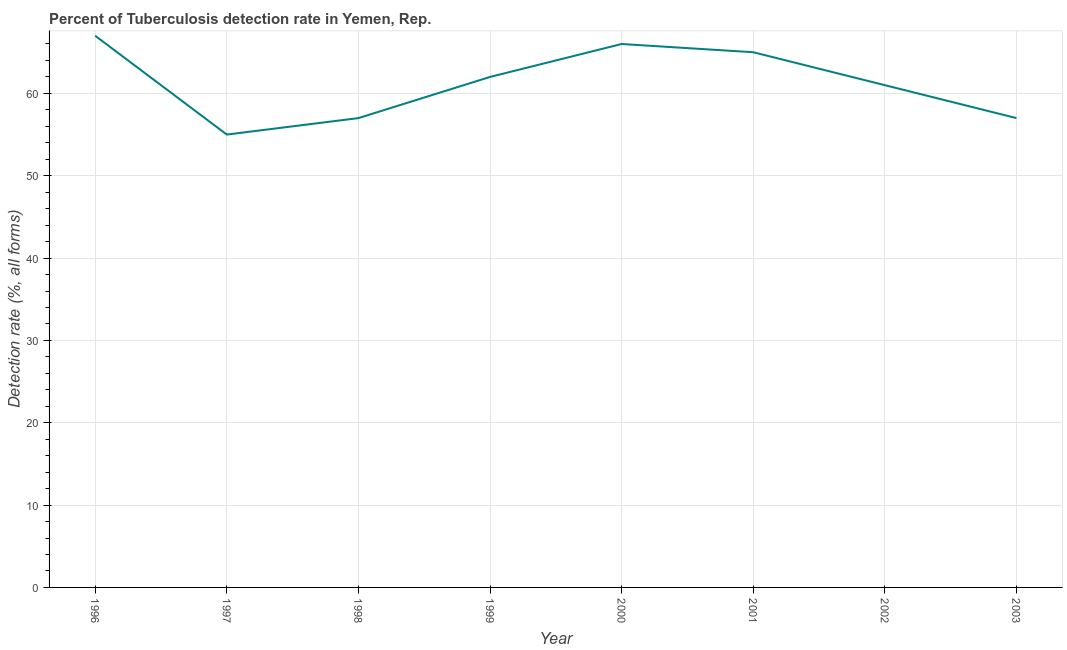What is the detection rate of tuberculosis in 1998?
Ensure brevity in your answer.  57. Across all years, what is the maximum detection rate of tuberculosis?
Your answer should be compact. 67. Across all years, what is the minimum detection rate of tuberculosis?
Make the answer very short. 55. What is the sum of the detection rate of tuberculosis?
Your response must be concise. 490. What is the difference between the detection rate of tuberculosis in 1998 and 2000?
Keep it short and to the point. -9. What is the average detection rate of tuberculosis per year?
Ensure brevity in your answer.  61.25. What is the median detection rate of tuberculosis?
Your answer should be compact. 61.5. In how many years, is the detection rate of tuberculosis greater than 40 %?
Provide a succinct answer. 8. Do a majority of the years between 1999 and 1996 (inclusive) have detection rate of tuberculosis greater than 28 %?
Your answer should be compact. Yes. What is the ratio of the detection rate of tuberculosis in 1996 to that in 1998?
Your answer should be very brief. 1.18. Is the difference between the detection rate of tuberculosis in 1997 and 2002 greater than the difference between any two years?
Offer a terse response. No. What is the difference between the highest and the second highest detection rate of tuberculosis?
Keep it short and to the point. 1. What is the difference between the highest and the lowest detection rate of tuberculosis?
Your answer should be very brief. 12. In how many years, is the detection rate of tuberculosis greater than the average detection rate of tuberculosis taken over all years?
Your answer should be very brief. 4. Does the detection rate of tuberculosis monotonically increase over the years?
Your answer should be very brief. No. How many lines are there?
Ensure brevity in your answer.  1. Are the values on the major ticks of Y-axis written in scientific E-notation?
Give a very brief answer. No. Does the graph contain any zero values?
Offer a very short reply. No. What is the title of the graph?
Provide a succinct answer. Percent of Tuberculosis detection rate in Yemen, Rep. What is the label or title of the Y-axis?
Your answer should be very brief. Detection rate (%, all forms). What is the Detection rate (%, all forms) of 1997?
Keep it short and to the point. 55. What is the Detection rate (%, all forms) of 1999?
Provide a short and direct response. 62. What is the Detection rate (%, all forms) in 2003?
Offer a very short reply. 57. What is the difference between the Detection rate (%, all forms) in 1996 and 1999?
Your answer should be very brief. 5. What is the difference between the Detection rate (%, all forms) in 1996 and 2001?
Offer a terse response. 2. What is the difference between the Detection rate (%, all forms) in 1997 and 1999?
Offer a very short reply. -7. What is the difference between the Detection rate (%, all forms) in 1997 and 2001?
Ensure brevity in your answer.  -10. What is the difference between the Detection rate (%, all forms) in 1997 and 2002?
Offer a very short reply. -6. What is the difference between the Detection rate (%, all forms) in 1997 and 2003?
Make the answer very short. -2. What is the difference between the Detection rate (%, all forms) in 1998 and 2001?
Your answer should be very brief. -8. What is the difference between the Detection rate (%, all forms) in 1998 and 2002?
Ensure brevity in your answer.  -4. What is the difference between the Detection rate (%, all forms) in 1999 and 2001?
Ensure brevity in your answer.  -3. What is the difference between the Detection rate (%, all forms) in 1999 and 2002?
Offer a very short reply. 1. What is the difference between the Detection rate (%, all forms) in 1999 and 2003?
Make the answer very short. 5. What is the difference between the Detection rate (%, all forms) in 2000 and 2003?
Your answer should be compact. 9. What is the difference between the Detection rate (%, all forms) in 2001 and 2003?
Provide a short and direct response. 8. What is the difference between the Detection rate (%, all forms) in 2002 and 2003?
Ensure brevity in your answer.  4. What is the ratio of the Detection rate (%, all forms) in 1996 to that in 1997?
Ensure brevity in your answer.  1.22. What is the ratio of the Detection rate (%, all forms) in 1996 to that in 1998?
Offer a terse response. 1.18. What is the ratio of the Detection rate (%, all forms) in 1996 to that in 1999?
Provide a succinct answer. 1.08. What is the ratio of the Detection rate (%, all forms) in 1996 to that in 2000?
Your response must be concise. 1.01. What is the ratio of the Detection rate (%, all forms) in 1996 to that in 2001?
Ensure brevity in your answer.  1.03. What is the ratio of the Detection rate (%, all forms) in 1996 to that in 2002?
Ensure brevity in your answer.  1.1. What is the ratio of the Detection rate (%, all forms) in 1996 to that in 2003?
Offer a terse response. 1.18. What is the ratio of the Detection rate (%, all forms) in 1997 to that in 1999?
Provide a short and direct response. 0.89. What is the ratio of the Detection rate (%, all forms) in 1997 to that in 2000?
Your answer should be compact. 0.83. What is the ratio of the Detection rate (%, all forms) in 1997 to that in 2001?
Offer a very short reply. 0.85. What is the ratio of the Detection rate (%, all forms) in 1997 to that in 2002?
Your response must be concise. 0.9. What is the ratio of the Detection rate (%, all forms) in 1997 to that in 2003?
Offer a very short reply. 0.96. What is the ratio of the Detection rate (%, all forms) in 1998 to that in 1999?
Your answer should be compact. 0.92. What is the ratio of the Detection rate (%, all forms) in 1998 to that in 2000?
Ensure brevity in your answer.  0.86. What is the ratio of the Detection rate (%, all forms) in 1998 to that in 2001?
Make the answer very short. 0.88. What is the ratio of the Detection rate (%, all forms) in 1998 to that in 2002?
Make the answer very short. 0.93. What is the ratio of the Detection rate (%, all forms) in 1998 to that in 2003?
Offer a very short reply. 1. What is the ratio of the Detection rate (%, all forms) in 1999 to that in 2000?
Your answer should be compact. 0.94. What is the ratio of the Detection rate (%, all forms) in 1999 to that in 2001?
Your answer should be compact. 0.95. What is the ratio of the Detection rate (%, all forms) in 1999 to that in 2002?
Provide a short and direct response. 1.02. What is the ratio of the Detection rate (%, all forms) in 1999 to that in 2003?
Keep it short and to the point. 1.09. What is the ratio of the Detection rate (%, all forms) in 2000 to that in 2002?
Your answer should be compact. 1.08. What is the ratio of the Detection rate (%, all forms) in 2000 to that in 2003?
Offer a terse response. 1.16. What is the ratio of the Detection rate (%, all forms) in 2001 to that in 2002?
Your answer should be very brief. 1.07. What is the ratio of the Detection rate (%, all forms) in 2001 to that in 2003?
Provide a short and direct response. 1.14. What is the ratio of the Detection rate (%, all forms) in 2002 to that in 2003?
Keep it short and to the point. 1.07. 